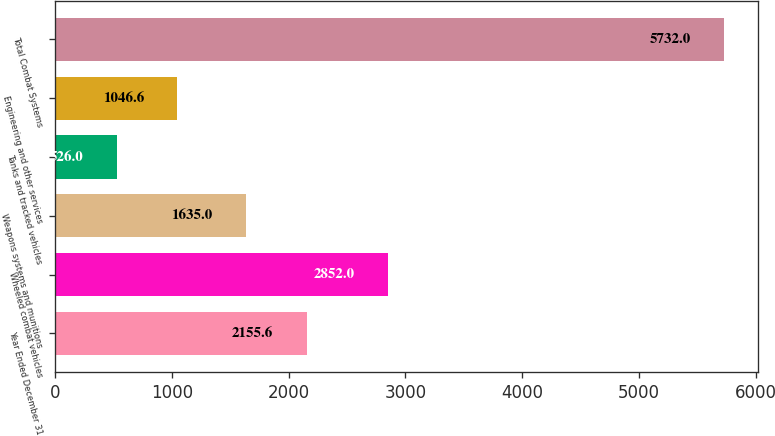Convert chart to OTSL. <chart><loc_0><loc_0><loc_500><loc_500><bar_chart><fcel>Year Ended December 31<fcel>Wheeled combat vehicles<fcel>Weapons systems and munitions<fcel>Tanks and tracked vehicles<fcel>Engineering and other services<fcel>Total Combat Systems<nl><fcel>2155.6<fcel>2852<fcel>1635<fcel>526<fcel>1046.6<fcel>5732<nl></chart> 